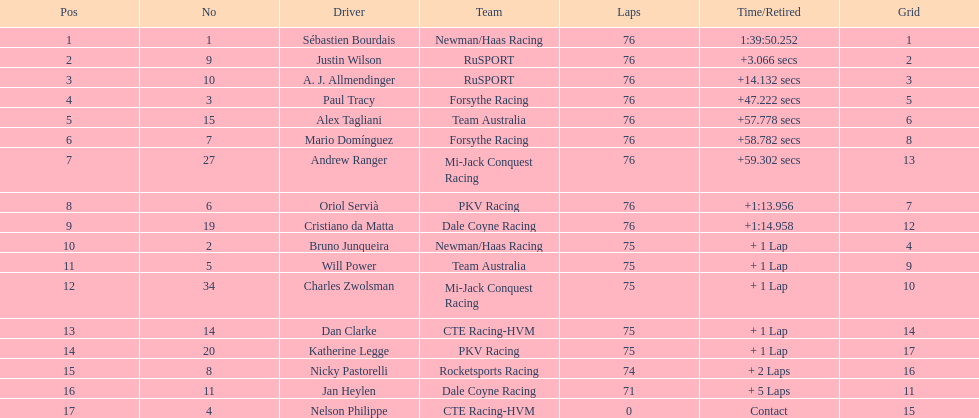Which canadian driver finished first: alex tagliani or paul tracy? Paul Tracy. 